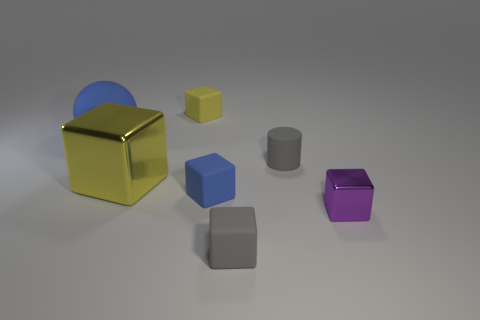Subtract all large yellow cubes. How many cubes are left? 4 Subtract all blue blocks. How many blocks are left? 4 Subtract all blue blocks. Subtract all cyan cylinders. How many blocks are left? 4 Add 3 large blocks. How many objects exist? 10 Subtract all cylinders. How many objects are left? 6 Subtract 0 red spheres. How many objects are left? 7 Subtract all small gray rubber cylinders. Subtract all small purple objects. How many objects are left? 5 Add 1 blue matte things. How many blue matte things are left? 3 Add 5 large balls. How many large balls exist? 6 